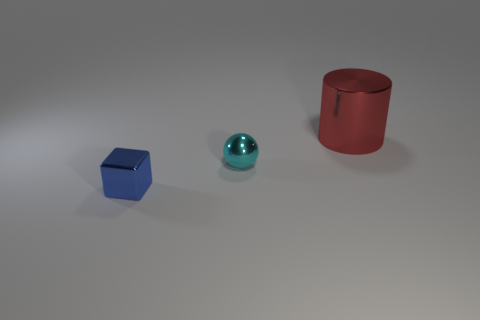Is the color of the small shiny block the same as the metallic thing to the right of the metal ball?
Keep it short and to the point. No. Is the number of red shiny things that are behind the cyan object greater than the number of blue metallic things?
Offer a terse response. No. What number of tiny metallic blocks are behind the small metal thing that is right of the tiny metal thing that is on the left side of the cyan metal thing?
Offer a very short reply. 0. Do the metal object that is on the right side of the cyan metallic ball and the cyan metallic thing have the same shape?
Make the answer very short. No. There is a thing that is behind the small cyan ball; what material is it?
Provide a short and direct response. Metal. What is the shape of the metal thing that is on the right side of the small blue object and in front of the large cylinder?
Keep it short and to the point. Sphere. Is the number of small cyan spheres the same as the number of small brown shiny spheres?
Your answer should be very brief. No. What material is the big red cylinder?
Ensure brevity in your answer.  Metal. How many cylinders are big green things or small objects?
Make the answer very short. 0. Do the small cyan sphere and the large red object have the same material?
Offer a very short reply. Yes. 